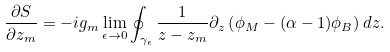Convert formula to latex. <formula><loc_0><loc_0><loc_500><loc_500>\frac { \partial S } { \partial z _ { m } } = - i g _ { m } \lim _ { \epsilon \rightarrow 0 } \oint _ { \gamma _ { \epsilon } } \frac { 1 } { z - z _ { m } } \partial _ { z } \left ( \phi _ { M } - ( \alpha - 1 ) \phi _ { B } \right ) d z .</formula> 